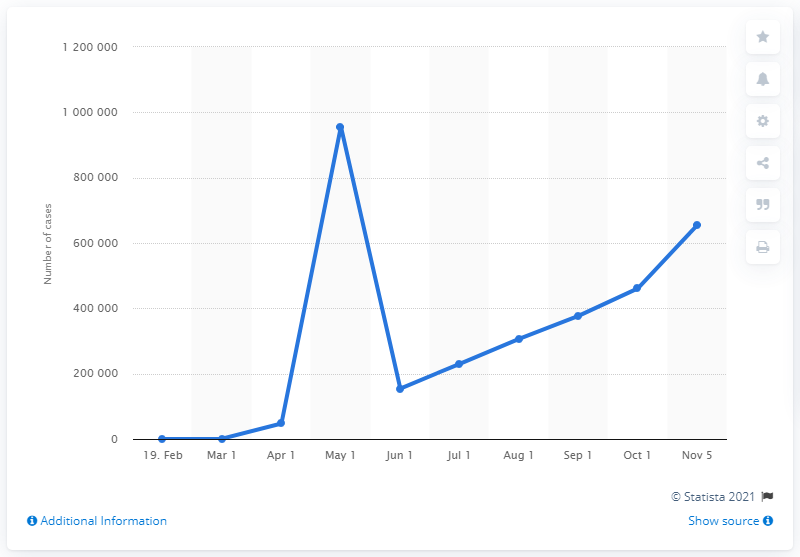Point out several critical features in this image. As of November 6, there have been 654,936 confirmed cases of COVID-19 in Iran. 